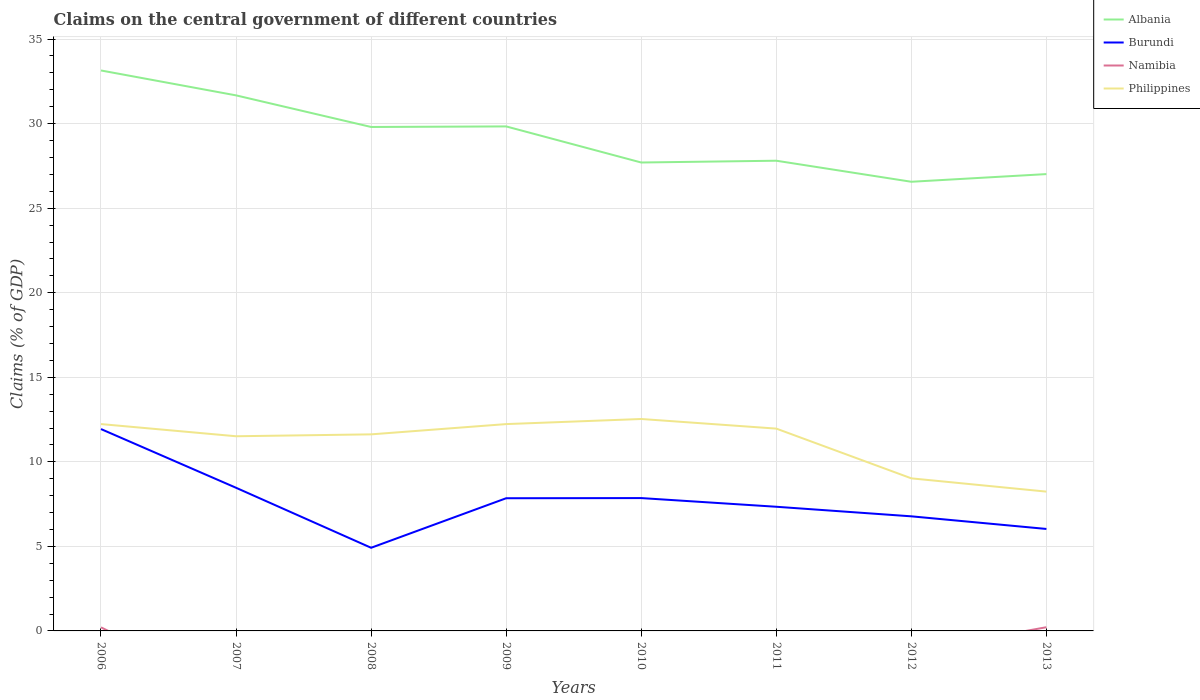Across all years, what is the maximum percentage of GDP claimed on the central government in Burundi?
Make the answer very short. 4.92. What is the total percentage of GDP claimed on the central government in Philippines in the graph?
Provide a succinct answer. 3.39. What is the difference between the highest and the second highest percentage of GDP claimed on the central government in Namibia?
Your answer should be compact. 0.22. What is the difference between the highest and the lowest percentage of GDP claimed on the central government in Philippines?
Your response must be concise. 6. How many lines are there?
Keep it short and to the point. 4. How many years are there in the graph?
Your answer should be very brief. 8. What is the difference between two consecutive major ticks on the Y-axis?
Keep it short and to the point. 5. Does the graph contain any zero values?
Keep it short and to the point. Yes. Where does the legend appear in the graph?
Your answer should be compact. Top right. How many legend labels are there?
Your response must be concise. 4. What is the title of the graph?
Your answer should be compact. Claims on the central government of different countries. Does "Kazakhstan" appear as one of the legend labels in the graph?
Provide a succinct answer. No. What is the label or title of the X-axis?
Provide a succinct answer. Years. What is the label or title of the Y-axis?
Give a very brief answer. Claims (% of GDP). What is the Claims (% of GDP) in Albania in 2006?
Keep it short and to the point. 33.14. What is the Claims (% of GDP) of Burundi in 2006?
Offer a very short reply. 11.94. What is the Claims (% of GDP) in Namibia in 2006?
Ensure brevity in your answer.  0.21. What is the Claims (% of GDP) of Philippines in 2006?
Give a very brief answer. 12.23. What is the Claims (% of GDP) of Albania in 2007?
Your answer should be compact. 31.67. What is the Claims (% of GDP) of Burundi in 2007?
Offer a very short reply. 8.47. What is the Claims (% of GDP) of Philippines in 2007?
Provide a short and direct response. 11.51. What is the Claims (% of GDP) in Albania in 2008?
Provide a succinct answer. 29.8. What is the Claims (% of GDP) in Burundi in 2008?
Your response must be concise. 4.92. What is the Claims (% of GDP) of Namibia in 2008?
Ensure brevity in your answer.  0. What is the Claims (% of GDP) in Philippines in 2008?
Your answer should be compact. 11.62. What is the Claims (% of GDP) of Albania in 2009?
Ensure brevity in your answer.  29.83. What is the Claims (% of GDP) of Burundi in 2009?
Ensure brevity in your answer.  7.85. What is the Claims (% of GDP) in Philippines in 2009?
Offer a terse response. 12.23. What is the Claims (% of GDP) of Albania in 2010?
Ensure brevity in your answer.  27.7. What is the Claims (% of GDP) in Burundi in 2010?
Your response must be concise. 7.86. What is the Claims (% of GDP) of Philippines in 2010?
Make the answer very short. 12.53. What is the Claims (% of GDP) in Albania in 2011?
Provide a succinct answer. 27.81. What is the Claims (% of GDP) in Burundi in 2011?
Your answer should be very brief. 7.34. What is the Claims (% of GDP) in Namibia in 2011?
Keep it short and to the point. 0. What is the Claims (% of GDP) in Philippines in 2011?
Your response must be concise. 11.96. What is the Claims (% of GDP) of Albania in 2012?
Make the answer very short. 26.56. What is the Claims (% of GDP) in Burundi in 2012?
Ensure brevity in your answer.  6.78. What is the Claims (% of GDP) of Namibia in 2012?
Your answer should be very brief. 0. What is the Claims (% of GDP) in Philippines in 2012?
Your response must be concise. 9.02. What is the Claims (% of GDP) of Albania in 2013?
Your answer should be very brief. 27.02. What is the Claims (% of GDP) in Burundi in 2013?
Offer a terse response. 6.03. What is the Claims (% of GDP) in Namibia in 2013?
Keep it short and to the point. 0.22. What is the Claims (% of GDP) in Philippines in 2013?
Offer a very short reply. 8.24. Across all years, what is the maximum Claims (% of GDP) of Albania?
Ensure brevity in your answer.  33.14. Across all years, what is the maximum Claims (% of GDP) in Burundi?
Your response must be concise. 11.94. Across all years, what is the maximum Claims (% of GDP) in Namibia?
Keep it short and to the point. 0.22. Across all years, what is the maximum Claims (% of GDP) in Philippines?
Provide a succinct answer. 12.53. Across all years, what is the minimum Claims (% of GDP) of Albania?
Your answer should be very brief. 26.56. Across all years, what is the minimum Claims (% of GDP) of Burundi?
Your answer should be very brief. 4.92. Across all years, what is the minimum Claims (% of GDP) of Namibia?
Your answer should be very brief. 0. Across all years, what is the minimum Claims (% of GDP) of Philippines?
Make the answer very short. 8.24. What is the total Claims (% of GDP) in Albania in the graph?
Provide a short and direct response. 233.54. What is the total Claims (% of GDP) of Burundi in the graph?
Provide a short and direct response. 61.17. What is the total Claims (% of GDP) of Namibia in the graph?
Give a very brief answer. 0.43. What is the total Claims (% of GDP) of Philippines in the graph?
Your answer should be compact. 89.36. What is the difference between the Claims (% of GDP) in Albania in 2006 and that in 2007?
Your response must be concise. 1.47. What is the difference between the Claims (% of GDP) in Burundi in 2006 and that in 2007?
Offer a very short reply. 3.47. What is the difference between the Claims (% of GDP) of Philippines in 2006 and that in 2007?
Keep it short and to the point. 0.72. What is the difference between the Claims (% of GDP) of Albania in 2006 and that in 2008?
Give a very brief answer. 3.34. What is the difference between the Claims (% of GDP) of Burundi in 2006 and that in 2008?
Your answer should be very brief. 7.02. What is the difference between the Claims (% of GDP) in Philippines in 2006 and that in 2008?
Offer a terse response. 0.61. What is the difference between the Claims (% of GDP) in Albania in 2006 and that in 2009?
Offer a terse response. 3.31. What is the difference between the Claims (% of GDP) in Burundi in 2006 and that in 2009?
Provide a short and direct response. 4.09. What is the difference between the Claims (% of GDP) of Philippines in 2006 and that in 2009?
Give a very brief answer. 0. What is the difference between the Claims (% of GDP) of Albania in 2006 and that in 2010?
Your answer should be very brief. 5.44. What is the difference between the Claims (% of GDP) in Burundi in 2006 and that in 2010?
Give a very brief answer. 4.08. What is the difference between the Claims (% of GDP) in Philippines in 2006 and that in 2010?
Your answer should be very brief. -0.3. What is the difference between the Claims (% of GDP) in Albania in 2006 and that in 2011?
Your answer should be very brief. 5.34. What is the difference between the Claims (% of GDP) of Burundi in 2006 and that in 2011?
Give a very brief answer. 4.59. What is the difference between the Claims (% of GDP) in Philippines in 2006 and that in 2011?
Offer a terse response. 0.27. What is the difference between the Claims (% of GDP) of Albania in 2006 and that in 2012?
Your answer should be compact. 6.58. What is the difference between the Claims (% of GDP) in Burundi in 2006 and that in 2012?
Keep it short and to the point. 5.16. What is the difference between the Claims (% of GDP) of Philippines in 2006 and that in 2012?
Your response must be concise. 3.21. What is the difference between the Claims (% of GDP) in Albania in 2006 and that in 2013?
Your answer should be very brief. 6.13. What is the difference between the Claims (% of GDP) of Burundi in 2006 and that in 2013?
Keep it short and to the point. 5.91. What is the difference between the Claims (% of GDP) of Namibia in 2006 and that in 2013?
Offer a very short reply. -0.01. What is the difference between the Claims (% of GDP) in Philippines in 2006 and that in 2013?
Provide a short and direct response. 3.99. What is the difference between the Claims (% of GDP) in Albania in 2007 and that in 2008?
Ensure brevity in your answer.  1.87. What is the difference between the Claims (% of GDP) in Burundi in 2007 and that in 2008?
Your answer should be compact. 3.55. What is the difference between the Claims (% of GDP) in Philippines in 2007 and that in 2008?
Ensure brevity in your answer.  -0.11. What is the difference between the Claims (% of GDP) in Albania in 2007 and that in 2009?
Make the answer very short. 1.84. What is the difference between the Claims (% of GDP) of Burundi in 2007 and that in 2009?
Offer a very short reply. 0.62. What is the difference between the Claims (% of GDP) of Philippines in 2007 and that in 2009?
Keep it short and to the point. -0.72. What is the difference between the Claims (% of GDP) of Albania in 2007 and that in 2010?
Provide a short and direct response. 3.97. What is the difference between the Claims (% of GDP) in Burundi in 2007 and that in 2010?
Offer a terse response. 0.61. What is the difference between the Claims (% of GDP) of Philippines in 2007 and that in 2010?
Make the answer very short. -1.02. What is the difference between the Claims (% of GDP) in Albania in 2007 and that in 2011?
Your response must be concise. 3.86. What is the difference between the Claims (% of GDP) in Burundi in 2007 and that in 2011?
Give a very brief answer. 1.12. What is the difference between the Claims (% of GDP) in Philippines in 2007 and that in 2011?
Make the answer very short. -0.45. What is the difference between the Claims (% of GDP) in Albania in 2007 and that in 2012?
Offer a terse response. 5.11. What is the difference between the Claims (% of GDP) of Burundi in 2007 and that in 2012?
Offer a terse response. 1.69. What is the difference between the Claims (% of GDP) in Philippines in 2007 and that in 2012?
Make the answer very short. 2.49. What is the difference between the Claims (% of GDP) in Albania in 2007 and that in 2013?
Make the answer very short. 4.66. What is the difference between the Claims (% of GDP) in Burundi in 2007 and that in 2013?
Offer a very short reply. 2.44. What is the difference between the Claims (% of GDP) of Philippines in 2007 and that in 2013?
Offer a very short reply. 3.27. What is the difference between the Claims (% of GDP) of Albania in 2008 and that in 2009?
Give a very brief answer. -0.03. What is the difference between the Claims (% of GDP) in Burundi in 2008 and that in 2009?
Your answer should be very brief. -2.93. What is the difference between the Claims (% of GDP) of Philippines in 2008 and that in 2009?
Your response must be concise. -0.61. What is the difference between the Claims (% of GDP) of Albania in 2008 and that in 2010?
Keep it short and to the point. 2.1. What is the difference between the Claims (% of GDP) in Burundi in 2008 and that in 2010?
Make the answer very short. -2.94. What is the difference between the Claims (% of GDP) in Philippines in 2008 and that in 2010?
Keep it short and to the point. -0.91. What is the difference between the Claims (% of GDP) of Albania in 2008 and that in 2011?
Make the answer very short. 2. What is the difference between the Claims (% of GDP) in Burundi in 2008 and that in 2011?
Make the answer very short. -2.43. What is the difference between the Claims (% of GDP) of Philippines in 2008 and that in 2011?
Provide a short and direct response. -0.34. What is the difference between the Claims (% of GDP) of Albania in 2008 and that in 2012?
Your answer should be very brief. 3.24. What is the difference between the Claims (% of GDP) of Burundi in 2008 and that in 2012?
Ensure brevity in your answer.  -1.86. What is the difference between the Claims (% of GDP) of Philippines in 2008 and that in 2012?
Your response must be concise. 2.6. What is the difference between the Claims (% of GDP) in Albania in 2008 and that in 2013?
Ensure brevity in your answer.  2.79. What is the difference between the Claims (% of GDP) in Burundi in 2008 and that in 2013?
Provide a short and direct response. -1.11. What is the difference between the Claims (% of GDP) in Philippines in 2008 and that in 2013?
Make the answer very short. 3.39. What is the difference between the Claims (% of GDP) in Albania in 2009 and that in 2010?
Your answer should be compact. 2.13. What is the difference between the Claims (% of GDP) in Burundi in 2009 and that in 2010?
Provide a short and direct response. -0.01. What is the difference between the Claims (% of GDP) of Philippines in 2009 and that in 2010?
Keep it short and to the point. -0.3. What is the difference between the Claims (% of GDP) of Albania in 2009 and that in 2011?
Offer a terse response. 2.03. What is the difference between the Claims (% of GDP) of Burundi in 2009 and that in 2011?
Your answer should be very brief. 0.5. What is the difference between the Claims (% of GDP) in Philippines in 2009 and that in 2011?
Offer a very short reply. 0.27. What is the difference between the Claims (% of GDP) of Albania in 2009 and that in 2012?
Your response must be concise. 3.27. What is the difference between the Claims (% of GDP) in Burundi in 2009 and that in 2012?
Your answer should be very brief. 1.07. What is the difference between the Claims (% of GDP) of Philippines in 2009 and that in 2012?
Your response must be concise. 3.21. What is the difference between the Claims (% of GDP) in Albania in 2009 and that in 2013?
Give a very brief answer. 2.82. What is the difference between the Claims (% of GDP) in Burundi in 2009 and that in 2013?
Offer a very short reply. 1.82. What is the difference between the Claims (% of GDP) of Philippines in 2009 and that in 2013?
Give a very brief answer. 3.99. What is the difference between the Claims (% of GDP) of Albania in 2010 and that in 2011?
Your answer should be compact. -0.11. What is the difference between the Claims (% of GDP) of Burundi in 2010 and that in 2011?
Keep it short and to the point. 0.51. What is the difference between the Claims (% of GDP) of Philippines in 2010 and that in 2011?
Provide a succinct answer. 0.57. What is the difference between the Claims (% of GDP) of Albania in 2010 and that in 2012?
Your answer should be compact. 1.14. What is the difference between the Claims (% of GDP) of Burundi in 2010 and that in 2012?
Provide a short and direct response. 1.08. What is the difference between the Claims (% of GDP) of Philippines in 2010 and that in 2012?
Provide a short and direct response. 3.51. What is the difference between the Claims (% of GDP) of Albania in 2010 and that in 2013?
Your response must be concise. 0.69. What is the difference between the Claims (% of GDP) of Burundi in 2010 and that in 2013?
Your answer should be compact. 1.83. What is the difference between the Claims (% of GDP) of Philippines in 2010 and that in 2013?
Your response must be concise. 4.3. What is the difference between the Claims (% of GDP) of Albania in 2011 and that in 2012?
Provide a succinct answer. 1.24. What is the difference between the Claims (% of GDP) of Burundi in 2011 and that in 2012?
Provide a succinct answer. 0.57. What is the difference between the Claims (% of GDP) of Philippines in 2011 and that in 2012?
Make the answer very short. 2.94. What is the difference between the Claims (% of GDP) of Albania in 2011 and that in 2013?
Offer a terse response. 0.79. What is the difference between the Claims (% of GDP) in Burundi in 2011 and that in 2013?
Your answer should be very brief. 1.31. What is the difference between the Claims (% of GDP) of Philippines in 2011 and that in 2013?
Keep it short and to the point. 3.73. What is the difference between the Claims (% of GDP) of Albania in 2012 and that in 2013?
Your answer should be compact. -0.45. What is the difference between the Claims (% of GDP) of Burundi in 2012 and that in 2013?
Your answer should be compact. 0.75. What is the difference between the Claims (% of GDP) of Philippines in 2012 and that in 2013?
Ensure brevity in your answer.  0.79. What is the difference between the Claims (% of GDP) in Albania in 2006 and the Claims (% of GDP) in Burundi in 2007?
Your answer should be very brief. 24.68. What is the difference between the Claims (% of GDP) in Albania in 2006 and the Claims (% of GDP) in Philippines in 2007?
Offer a very short reply. 21.63. What is the difference between the Claims (% of GDP) in Burundi in 2006 and the Claims (% of GDP) in Philippines in 2007?
Your answer should be compact. 0.43. What is the difference between the Claims (% of GDP) of Namibia in 2006 and the Claims (% of GDP) of Philippines in 2007?
Keep it short and to the point. -11.3. What is the difference between the Claims (% of GDP) in Albania in 2006 and the Claims (% of GDP) in Burundi in 2008?
Provide a succinct answer. 28.23. What is the difference between the Claims (% of GDP) in Albania in 2006 and the Claims (% of GDP) in Philippines in 2008?
Provide a short and direct response. 21.52. What is the difference between the Claims (% of GDP) of Burundi in 2006 and the Claims (% of GDP) of Philippines in 2008?
Provide a succinct answer. 0.31. What is the difference between the Claims (% of GDP) in Namibia in 2006 and the Claims (% of GDP) in Philippines in 2008?
Make the answer very short. -11.41. What is the difference between the Claims (% of GDP) in Albania in 2006 and the Claims (% of GDP) in Burundi in 2009?
Provide a short and direct response. 25.3. What is the difference between the Claims (% of GDP) of Albania in 2006 and the Claims (% of GDP) of Philippines in 2009?
Give a very brief answer. 20.91. What is the difference between the Claims (% of GDP) of Burundi in 2006 and the Claims (% of GDP) of Philippines in 2009?
Make the answer very short. -0.29. What is the difference between the Claims (% of GDP) in Namibia in 2006 and the Claims (% of GDP) in Philippines in 2009?
Provide a short and direct response. -12.02. What is the difference between the Claims (% of GDP) in Albania in 2006 and the Claims (% of GDP) in Burundi in 2010?
Make the answer very short. 25.29. What is the difference between the Claims (% of GDP) in Albania in 2006 and the Claims (% of GDP) in Philippines in 2010?
Provide a short and direct response. 20.61. What is the difference between the Claims (% of GDP) of Burundi in 2006 and the Claims (% of GDP) of Philippines in 2010?
Ensure brevity in your answer.  -0.6. What is the difference between the Claims (% of GDP) of Namibia in 2006 and the Claims (% of GDP) of Philippines in 2010?
Your answer should be compact. -12.32. What is the difference between the Claims (% of GDP) of Albania in 2006 and the Claims (% of GDP) of Burundi in 2011?
Give a very brief answer. 25.8. What is the difference between the Claims (% of GDP) of Albania in 2006 and the Claims (% of GDP) of Philippines in 2011?
Ensure brevity in your answer.  21.18. What is the difference between the Claims (% of GDP) of Burundi in 2006 and the Claims (% of GDP) of Philippines in 2011?
Provide a short and direct response. -0.03. What is the difference between the Claims (% of GDP) of Namibia in 2006 and the Claims (% of GDP) of Philippines in 2011?
Offer a very short reply. -11.75. What is the difference between the Claims (% of GDP) of Albania in 2006 and the Claims (% of GDP) of Burundi in 2012?
Give a very brief answer. 26.37. What is the difference between the Claims (% of GDP) of Albania in 2006 and the Claims (% of GDP) of Philippines in 2012?
Your answer should be compact. 24.12. What is the difference between the Claims (% of GDP) in Burundi in 2006 and the Claims (% of GDP) in Philippines in 2012?
Your response must be concise. 2.91. What is the difference between the Claims (% of GDP) of Namibia in 2006 and the Claims (% of GDP) of Philippines in 2012?
Ensure brevity in your answer.  -8.81. What is the difference between the Claims (% of GDP) of Albania in 2006 and the Claims (% of GDP) of Burundi in 2013?
Offer a terse response. 27.11. What is the difference between the Claims (% of GDP) in Albania in 2006 and the Claims (% of GDP) in Namibia in 2013?
Your answer should be very brief. 32.92. What is the difference between the Claims (% of GDP) in Albania in 2006 and the Claims (% of GDP) in Philippines in 2013?
Your response must be concise. 24.91. What is the difference between the Claims (% of GDP) of Burundi in 2006 and the Claims (% of GDP) of Namibia in 2013?
Provide a short and direct response. 11.72. What is the difference between the Claims (% of GDP) of Burundi in 2006 and the Claims (% of GDP) of Philippines in 2013?
Keep it short and to the point. 3.7. What is the difference between the Claims (% of GDP) of Namibia in 2006 and the Claims (% of GDP) of Philippines in 2013?
Your answer should be very brief. -8.03. What is the difference between the Claims (% of GDP) in Albania in 2007 and the Claims (% of GDP) in Burundi in 2008?
Ensure brevity in your answer.  26.75. What is the difference between the Claims (% of GDP) in Albania in 2007 and the Claims (% of GDP) in Philippines in 2008?
Ensure brevity in your answer.  20.05. What is the difference between the Claims (% of GDP) of Burundi in 2007 and the Claims (% of GDP) of Philippines in 2008?
Offer a very short reply. -3.16. What is the difference between the Claims (% of GDP) in Albania in 2007 and the Claims (% of GDP) in Burundi in 2009?
Make the answer very short. 23.82. What is the difference between the Claims (% of GDP) in Albania in 2007 and the Claims (% of GDP) in Philippines in 2009?
Your response must be concise. 19.44. What is the difference between the Claims (% of GDP) of Burundi in 2007 and the Claims (% of GDP) of Philippines in 2009?
Provide a succinct answer. -3.77. What is the difference between the Claims (% of GDP) in Albania in 2007 and the Claims (% of GDP) in Burundi in 2010?
Offer a very short reply. 23.82. What is the difference between the Claims (% of GDP) in Albania in 2007 and the Claims (% of GDP) in Philippines in 2010?
Keep it short and to the point. 19.14. What is the difference between the Claims (% of GDP) in Burundi in 2007 and the Claims (% of GDP) in Philippines in 2010?
Your response must be concise. -4.07. What is the difference between the Claims (% of GDP) of Albania in 2007 and the Claims (% of GDP) of Burundi in 2011?
Keep it short and to the point. 24.33. What is the difference between the Claims (% of GDP) in Albania in 2007 and the Claims (% of GDP) in Philippines in 2011?
Your response must be concise. 19.71. What is the difference between the Claims (% of GDP) in Burundi in 2007 and the Claims (% of GDP) in Philippines in 2011?
Your answer should be very brief. -3.5. What is the difference between the Claims (% of GDP) in Albania in 2007 and the Claims (% of GDP) in Burundi in 2012?
Ensure brevity in your answer.  24.89. What is the difference between the Claims (% of GDP) of Albania in 2007 and the Claims (% of GDP) of Philippines in 2012?
Your answer should be compact. 22.65. What is the difference between the Claims (% of GDP) in Burundi in 2007 and the Claims (% of GDP) in Philippines in 2012?
Your response must be concise. -0.56. What is the difference between the Claims (% of GDP) of Albania in 2007 and the Claims (% of GDP) of Burundi in 2013?
Offer a very short reply. 25.64. What is the difference between the Claims (% of GDP) in Albania in 2007 and the Claims (% of GDP) in Namibia in 2013?
Make the answer very short. 31.45. What is the difference between the Claims (% of GDP) in Albania in 2007 and the Claims (% of GDP) in Philippines in 2013?
Provide a succinct answer. 23.43. What is the difference between the Claims (% of GDP) in Burundi in 2007 and the Claims (% of GDP) in Namibia in 2013?
Make the answer very short. 8.25. What is the difference between the Claims (% of GDP) in Burundi in 2007 and the Claims (% of GDP) in Philippines in 2013?
Make the answer very short. 0.23. What is the difference between the Claims (% of GDP) in Albania in 2008 and the Claims (% of GDP) in Burundi in 2009?
Offer a terse response. 21.96. What is the difference between the Claims (% of GDP) of Albania in 2008 and the Claims (% of GDP) of Philippines in 2009?
Make the answer very short. 17.57. What is the difference between the Claims (% of GDP) of Burundi in 2008 and the Claims (% of GDP) of Philippines in 2009?
Your response must be concise. -7.31. What is the difference between the Claims (% of GDP) of Albania in 2008 and the Claims (% of GDP) of Burundi in 2010?
Make the answer very short. 21.95. What is the difference between the Claims (% of GDP) of Albania in 2008 and the Claims (% of GDP) of Philippines in 2010?
Make the answer very short. 17.27. What is the difference between the Claims (% of GDP) of Burundi in 2008 and the Claims (% of GDP) of Philippines in 2010?
Your response must be concise. -7.62. What is the difference between the Claims (% of GDP) in Albania in 2008 and the Claims (% of GDP) in Burundi in 2011?
Your answer should be compact. 22.46. What is the difference between the Claims (% of GDP) of Albania in 2008 and the Claims (% of GDP) of Philippines in 2011?
Keep it short and to the point. 17.84. What is the difference between the Claims (% of GDP) in Burundi in 2008 and the Claims (% of GDP) in Philippines in 2011?
Make the answer very short. -7.05. What is the difference between the Claims (% of GDP) of Albania in 2008 and the Claims (% of GDP) of Burundi in 2012?
Offer a terse response. 23.03. What is the difference between the Claims (% of GDP) in Albania in 2008 and the Claims (% of GDP) in Philippines in 2012?
Make the answer very short. 20.78. What is the difference between the Claims (% of GDP) in Burundi in 2008 and the Claims (% of GDP) in Philippines in 2012?
Keep it short and to the point. -4.11. What is the difference between the Claims (% of GDP) of Albania in 2008 and the Claims (% of GDP) of Burundi in 2013?
Your answer should be very brief. 23.77. What is the difference between the Claims (% of GDP) of Albania in 2008 and the Claims (% of GDP) of Namibia in 2013?
Offer a very short reply. 29.58. What is the difference between the Claims (% of GDP) of Albania in 2008 and the Claims (% of GDP) of Philippines in 2013?
Make the answer very short. 21.56. What is the difference between the Claims (% of GDP) of Burundi in 2008 and the Claims (% of GDP) of Namibia in 2013?
Provide a succinct answer. 4.7. What is the difference between the Claims (% of GDP) in Burundi in 2008 and the Claims (% of GDP) in Philippines in 2013?
Your answer should be compact. -3.32. What is the difference between the Claims (% of GDP) in Albania in 2009 and the Claims (% of GDP) in Burundi in 2010?
Provide a short and direct response. 21.98. What is the difference between the Claims (% of GDP) in Albania in 2009 and the Claims (% of GDP) in Philippines in 2010?
Your answer should be very brief. 17.3. What is the difference between the Claims (% of GDP) of Burundi in 2009 and the Claims (% of GDP) of Philippines in 2010?
Offer a very short reply. -4.69. What is the difference between the Claims (% of GDP) of Albania in 2009 and the Claims (% of GDP) of Burundi in 2011?
Your answer should be compact. 22.49. What is the difference between the Claims (% of GDP) in Albania in 2009 and the Claims (% of GDP) in Philippines in 2011?
Your answer should be compact. 17.87. What is the difference between the Claims (% of GDP) in Burundi in 2009 and the Claims (% of GDP) in Philippines in 2011?
Your answer should be compact. -4.12. What is the difference between the Claims (% of GDP) in Albania in 2009 and the Claims (% of GDP) in Burundi in 2012?
Your answer should be compact. 23.06. What is the difference between the Claims (% of GDP) in Albania in 2009 and the Claims (% of GDP) in Philippines in 2012?
Provide a short and direct response. 20.81. What is the difference between the Claims (% of GDP) of Burundi in 2009 and the Claims (% of GDP) of Philippines in 2012?
Give a very brief answer. -1.18. What is the difference between the Claims (% of GDP) of Albania in 2009 and the Claims (% of GDP) of Burundi in 2013?
Provide a short and direct response. 23.8. What is the difference between the Claims (% of GDP) of Albania in 2009 and the Claims (% of GDP) of Namibia in 2013?
Your answer should be compact. 29.62. What is the difference between the Claims (% of GDP) in Albania in 2009 and the Claims (% of GDP) in Philippines in 2013?
Offer a terse response. 21.6. What is the difference between the Claims (% of GDP) in Burundi in 2009 and the Claims (% of GDP) in Namibia in 2013?
Provide a short and direct response. 7.63. What is the difference between the Claims (% of GDP) in Burundi in 2009 and the Claims (% of GDP) in Philippines in 2013?
Your response must be concise. -0.39. What is the difference between the Claims (% of GDP) in Albania in 2010 and the Claims (% of GDP) in Burundi in 2011?
Make the answer very short. 20.36. What is the difference between the Claims (% of GDP) in Albania in 2010 and the Claims (% of GDP) in Philippines in 2011?
Keep it short and to the point. 15.74. What is the difference between the Claims (% of GDP) of Burundi in 2010 and the Claims (% of GDP) of Philippines in 2011?
Provide a short and direct response. -4.11. What is the difference between the Claims (% of GDP) in Albania in 2010 and the Claims (% of GDP) in Burundi in 2012?
Make the answer very short. 20.92. What is the difference between the Claims (% of GDP) of Albania in 2010 and the Claims (% of GDP) of Philippines in 2012?
Offer a very short reply. 18.68. What is the difference between the Claims (% of GDP) of Burundi in 2010 and the Claims (% of GDP) of Philippines in 2012?
Offer a very short reply. -1.17. What is the difference between the Claims (% of GDP) of Albania in 2010 and the Claims (% of GDP) of Burundi in 2013?
Provide a succinct answer. 21.67. What is the difference between the Claims (% of GDP) in Albania in 2010 and the Claims (% of GDP) in Namibia in 2013?
Your answer should be very brief. 27.48. What is the difference between the Claims (% of GDP) in Albania in 2010 and the Claims (% of GDP) in Philippines in 2013?
Provide a succinct answer. 19.46. What is the difference between the Claims (% of GDP) in Burundi in 2010 and the Claims (% of GDP) in Namibia in 2013?
Your answer should be very brief. 7.64. What is the difference between the Claims (% of GDP) of Burundi in 2010 and the Claims (% of GDP) of Philippines in 2013?
Provide a succinct answer. -0.38. What is the difference between the Claims (% of GDP) in Albania in 2011 and the Claims (% of GDP) in Burundi in 2012?
Your answer should be very brief. 21.03. What is the difference between the Claims (% of GDP) in Albania in 2011 and the Claims (% of GDP) in Philippines in 2012?
Ensure brevity in your answer.  18.78. What is the difference between the Claims (% of GDP) in Burundi in 2011 and the Claims (% of GDP) in Philippines in 2012?
Offer a very short reply. -1.68. What is the difference between the Claims (% of GDP) of Albania in 2011 and the Claims (% of GDP) of Burundi in 2013?
Offer a terse response. 21.78. What is the difference between the Claims (% of GDP) in Albania in 2011 and the Claims (% of GDP) in Namibia in 2013?
Provide a succinct answer. 27.59. What is the difference between the Claims (% of GDP) in Albania in 2011 and the Claims (% of GDP) in Philippines in 2013?
Your answer should be very brief. 19.57. What is the difference between the Claims (% of GDP) of Burundi in 2011 and the Claims (% of GDP) of Namibia in 2013?
Provide a short and direct response. 7.12. What is the difference between the Claims (% of GDP) of Burundi in 2011 and the Claims (% of GDP) of Philippines in 2013?
Keep it short and to the point. -0.9. What is the difference between the Claims (% of GDP) in Albania in 2012 and the Claims (% of GDP) in Burundi in 2013?
Keep it short and to the point. 20.53. What is the difference between the Claims (% of GDP) in Albania in 2012 and the Claims (% of GDP) in Namibia in 2013?
Keep it short and to the point. 26.34. What is the difference between the Claims (% of GDP) in Albania in 2012 and the Claims (% of GDP) in Philippines in 2013?
Your response must be concise. 18.32. What is the difference between the Claims (% of GDP) of Burundi in 2012 and the Claims (% of GDP) of Namibia in 2013?
Offer a very short reply. 6.56. What is the difference between the Claims (% of GDP) of Burundi in 2012 and the Claims (% of GDP) of Philippines in 2013?
Make the answer very short. -1.46. What is the average Claims (% of GDP) of Albania per year?
Provide a succinct answer. 29.19. What is the average Claims (% of GDP) in Burundi per year?
Offer a terse response. 7.65. What is the average Claims (% of GDP) of Namibia per year?
Your answer should be compact. 0.05. What is the average Claims (% of GDP) of Philippines per year?
Provide a short and direct response. 11.17. In the year 2006, what is the difference between the Claims (% of GDP) in Albania and Claims (% of GDP) in Burundi?
Your response must be concise. 21.21. In the year 2006, what is the difference between the Claims (% of GDP) of Albania and Claims (% of GDP) of Namibia?
Your answer should be compact. 32.93. In the year 2006, what is the difference between the Claims (% of GDP) of Albania and Claims (% of GDP) of Philippines?
Give a very brief answer. 20.91. In the year 2006, what is the difference between the Claims (% of GDP) in Burundi and Claims (% of GDP) in Namibia?
Keep it short and to the point. 11.73. In the year 2006, what is the difference between the Claims (% of GDP) of Burundi and Claims (% of GDP) of Philippines?
Make the answer very short. -0.29. In the year 2006, what is the difference between the Claims (% of GDP) in Namibia and Claims (% of GDP) in Philippines?
Make the answer very short. -12.02. In the year 2007, what is the difference between the Claims (% of GDP) of Albania and Claims (% of GDP) of Burundi?
Provide a short and direct response. 23.21. In the year 2007, what is the difference between the Claims (% of GDP) of Albania and Claims (% of GDP) of Philippines?
Ensure brevity in your answer.  20.16. In the year 2007, what is the difference between the Claims (% of GDP) in Burundi and Claims (% of GDP) in Philippines?
Offer a very short reply. -3.05. In the year 2008, what is the difference between the Claims (% of GDP) in Albania and Claims (% of GDP) in Burundi?
Your answer should be very brief. 24.89. In the year 2008, what is the difference between the Claims (% of GDP) of Albania and Claims (% of GDP) of Philippines?
Your answer should be compact. 18.18. In the year 2008, what is the difference between the Claims (% of GDP) in Burundi and Claims (% of GDP) in Philippines?
Your response must be concise. -6.71. In the year 2009, what is the difference between the Claims (% of GDP) of Albania and Claims (% of GDP) of Burundi?
Offer a terse response. 21.99. In the year 2009, what is the difference between the Claims (% of GDP) of Albania and Claims (% of GDP) of Philippines?
Provide a succinct answer. 17.6. In the year 2009, what is the difference between the Claims (% of GDP) of Burundi and Claims (% of GDP) of Philippines?
Provide a short and direct response. -4.38. In the year 2010, what is the difference between the Claims (% of GDP) in Albania and Claims (% of GDP) in Burundi?
Your response must be concise. 19.85. In the year 2010, what is the difference between the Claims (% of GDP) in Albania and Claims (% of GDP) in Philippines?
Your answer should be very brief. 15.17. In the year 2010, what is the difference between the Claims (% of GDP) in Burundi and Claims (% of GDP) in Philippines?
Offer a terse response. -4.68. In the year 2011, what is the difference between the Claims (% of GDP) of Albania and Claims (% of GDP) of Burundi?
Ensure brevity in your answer.  20.46. In the year 2011, what is the difference between the Claims (% of GDP) in Albania and Claims (% of GDP) in Philippines?
Your answer should be compact. 15.84. In the year 2011, what is the difference between the Claims (% of GDP) of Burundi and Claims (% of GDP) of Philippines?
Provide a short and direct response. -4.62. In the year 2012, what is the difference between the Claims (% of GDP) of Albania and Claims (% of GDP) of Burundi?
Ensure brevity in your answer.  19.79. In the year 2012, what is the difference between the Claims (% of GDP) of Albania and Claims (% of GDP) of Philippines?
Your response must be concise. 17.54. In the year 2012, what is the difference between the Claims (% of GDP) of Burundi and Claims (% of GDP) of Philippines?
Provide a succinct answer. -2.25. In the year 2013, what is the difference between the Claims (% of GDP) in Albania and Claims (% of GDP) in Burundi?
Offer a very short reply. 20.99. In the year 2013, what is the difference between the Claims (% of GDP) in Albania and Claims (% of GDP) in Namibia?
Keep it short and to the point. 26.8. In the year 2013, what is the difference between the Claims (% of GDP) of Albania and Claims (% of GDP) of Philippines?
Ensure brevity in your answer.  18.78. In the year 2013, what is the difference between the Claims (% of GDP) of Burundi and Claims (% of GDP) of Namibia?
Offer a very short reply. 5.81. In the year 2013, what is the difference between the Claims (% of GDP) of Burundi and Claims (% of GDP) of Philippines?
Keep it short and to the point. -2.21. In the year 2013, what is the difference between the Claims (% of GDP) in Namibia and Claims (% of GDP) in Philippines?
Your answer should be compact. -8.02. What is the ratio of the Claims (% of GDP) in Albania in 2006 to that in 2007?
Offer a very short reply. 1.05. What is the ratio of the Claims (% of GDP) of Burundi in 2006 to that in 2007?
Give a very brief answer. 1.41. What is the ratio of the Claims (% of GDP) in Albania in 2006 to that in 2008?
Give a very brief answer. 1.11. What is the ratio of the Claims (% of GDP) in Burundi in 2006 to that in 2008?
Make the answer very short. 2.43. What is the ratio of the Claims (% of GDP) of Philippines in 2006 to that in 2008?
Provide a short and direct response. 1.05. What is the ratio of the Claims (% of GDP) of Albania in 2006 to that in 2009?
Your answer should be compact. 1.11. What is the ratio of the Claims (% of GDP) of Burundi in 2006 to that in 2009?
Give a very brief answer. 1.52. What is the ratio of the Claims (% of GDP) of Albania in 2006 to that in 2010?
Offer a terse response. 1.2. What is the ratio of the Claims (% of GDP) of Burundi in 2006 to that in 2010?
Provide a succinct answer. 1.52. What is the ratio of the Claims (% of GDP) in Albania in 2006 to that in 2011?
Provide a short and direct response. 1.19. What is the ratio of the Claims (% of GDP) of Burundi in 2006 to that in 2011?
Your answer should be compact. 1.63. What is the ratio of the Claims (% of GDP) of Philippines in 2006 to that in 2011?
Provide a succinct answer. 1.02. What is the ratio of the Claims (% of GDP) in Albania in 2006 to that in 2012?
Provide a short and direct response. 1.25. What is the ratio of the Claims (% of GDP) of Burundi in 2006 to that in 2012?
Provide a succinct answer. 1.76. What is the ratio of the Claims (% of GDP) of Philippines in 2006 to that in 2012?
Provide a succinct answer. 1.36. What is the ratio of the Claims (% of GDP) in Albania in 2006 to that in 2013?
Give a very brief answer. 1.23. What is the ratio of the Claims (% of GDP) in Burundi in 2006 to that in 2013?
Offer a terse response. 1.98. What is the ratio of the Claims (% of GDP) in Namibia in 2006 to that in 2013?
Your response must be concise. 0.96. What is the ratio of the Claims (% of GDP) of Philippines in 2006 to that in 2013?
Ensure brevity in your answer.  1.48. What is the ratio of the Claims (% of GDP) of Albania in 2007 to that in 2008?
Give a very brief answer. 1.06. What is the ratio of the Claims (% of GDP) in Burundi in 2007 to that in 2008?
Offer a terse response. 1.72. What is the ratio of the Claims (% of GDP) of Albania in 2007 to that in 2009?
Provide a short and direct response. 1.06. What is the ratio of the Claims (% of GDP) of Burundi in 2007 to that in 2009?
Keep it short and to the point. 1.08. What is the ratio of the Claims (% of GDP) in Albania in 2007 to that in 2010?
Your answer should be very brief. 1.14. What is the ratio of the Claims (% of GDP) of Burundi in 2007 to that in 2010?
Your response must be concise. 1.08. What is the ratio of the Claims (% of GDP) of Philippines in 2007 to that in 2010?
Your answer should be compact. 0.92. What is the ratio of the Claims (% of GDP) in Albania in 2007 to that in 2011?
Make the answer very short. 1.14. What is the ratio of the Claims (% of GDP) in Burundi in 2007 to that in 2011?
Your response must be concise. 1.15. What is the ratio of the Claims (% of GDP) of Philippines in 2007 to that in 2011?
Keep it short and to the point. 0.96. What is the ratio of the Claims (% of GDP) of Albania in 2007 to that in 2012?
Your answer should be very brief. 1.19. What is the ratio of the Claims (% of GDP) in Burundi in 2007 to that in 2012?
Your answer should be compact. 1.25. What is the ratio of the Claims (% of GDP) of Philippines in 2007 to that in 2012?
Provide a succinct answer. 1.28. What is the ratio of the Claims (% of GDP) in Albania in 2007 to that in 2013?
Your answer should be compact. 1.17. What is the ratio of the Claims (% of GDP) of Burundi in 2007 to that in 2013?
Give a very brief answer. 1.4. What is the ratio of the Claims (% of GDP) in Philippines in 2007 to that in 2013?
Your answer should be very brief. 1.4. What is the ratio of the Claims (% of GDP) of Albania in 2008 to that in 2009?
Your answer should be very brief. 1. What is the ratio of the Claims (% of GDP) in Burundi in 2008 to that in 2009?
Your answer should be compact. 0.63. What is the ratio of the Claims (% of GDP) in Philippines in 2008 to that in 2009?
Make the answer very short. 0.95. What is the ratio of the Claims (% of GDP) of Albania in 2008 to that in 2010?
Your answer should be compact. 1.08. What is the ratio of the Claims (% of GDP) in Burundi in 2008 to that in 2010?
Make the answer very short. 0.63. What is the ratio of the Claims (% of GDP) of Philippines in 2008 to that in 2010?
Give a very brief answer. 0.93. What is the ratio of the Claims (% of GDP) in Albania in 2008 to that in 2011?
Make the answer very short. 1.07. What is the ratio of the Claims (% of GDP) in Burundi in 2008 to that in 2011?
Offer a terse response. 0.67. What is the ratio of the Claims (% of GDP) in Philippines in 2008 to that in 2011?
Provide a succinct answer. 0.97. What is the ratio of the Claims (% of GDP) of Albania in 2008 to that in 2012?
Keep it short and to the point. 1.12. What is the ratio of the Claims (% of GDP) of Burundi in 2008 to that in 2012?
Your answer should be compact. 0.73. What is the ratio of the Claims (% of GDP) in Philippines in 2008 to that in 2012?
Provide a short and direct response. 1.29. What is the ratio of the Claims (% of GDP) of Albania in 2008 to that in 2013?
Ensure brevity in your answer.  1.1. What is the ratio of the Claims (% of GDP) of Burundi in 2008 to that in 2013?
Your answer should be compact. 0.82. What is the ratio of the Claims (% of GDP) in Philippines in 2008 to that in 2013?
Ensure brevity in your answer.  1.41. What is the ratio of the Claims (% of GDP) in Albania in 2009 to that in 2010?
Offer a very short reply. 1.08. What is the ratio of the Claims (% of GDP) of Burundi in 2009 to that in 2010?
Your answer should be very brief. 1. What is the ratio of the Claims (% of GDP) of Philippines in 2009 to that in 2010?
Make the answer very short. 0.98. What is the ratio of the Claims (% of GDP) in Albania in 2009 to that in 2011?
Provide a short and direct response. 1.07. What is the ratio of the Claims (% of GDP) in Burundi in 2009 to that in 2011?
Your answer should be compact. 1.07. What is the ratio of the Claims (% of GDP) in Philippines in 2009 to that in 2011?
Give a very brief answer. 1.02. What is the ratio of the Claims (% of GDP) in Albania in 2009 to that in 2012?
Your response must be concise. 1.12. What is the ratio of the Claims (% of GDP) in Burundi in 2009 to that in 2012?
Keep it short and to the point. 1.16. What is the ratio of the Claims (% of GDP) in Philippines in 2009 to that in 2012?
Give a very brief answer. 1.36. What is the ratio of the Claims (% of GDP) in Albania in 2009 to that in 2013?
Provide a short and direct response. 1.1. What is the ratio of the Claims (% of GDP) in Burundi in 2009 to that in 2013?
Make the answer very short. 1.3. What is the ratio of the Claims (% of GDP) in Philippines in 2009 to that in 2013?
Your answer should be compact. 1.48. What is the ratio of the Claims (% of GDP) in Albania in 2010 to that in 2011?
Offer a terse response. 1. What is the ratio of the Claims (% of GDP) of Burundi in 2010 to that in 2011?
Make the answer very short. 1.07. What is the ratio of the Claims (% of GDP) in Philippines in 2010 to that in 2011?
Make the answer very short. 1.05. What is the ratio of the Claims (% of GDP) of Albania in 2010 to that in 2012?
Offer a terse response. 1.04. What is the ratio of the Claims (% of GDP) of Burundi in 2010 to that in 2012?
Make the answer very short. 1.16. What is the ratio of the Claims (% of GDP) in Philippines in 2010 to that in 2012?
Ensure brevity in your answer.  1.39. What is the ratio of the Claims (% of GDP) in Albania in 2010 to that in 2013?
Offer a terse response. 1.03. What is the ratio of the Claims (% of GDP) of Burundi in 2010 to that in 2013?
Provide a succinct answer. 1.3. What is the ratio of the Claims (% of GDP) in Philippines in 2010 to that in 2013?
Your response must be concise. 1.52. What is the ratio of the Claims (% of GDP) of Albania in 2011 to that in 2012?
Make the answer very short. 1.05. What is the ratio of the Claims (% of GDP) of Burundi in 2011 to that in 2012?
Provide a succinct answer. 1.08. What is the ratio of the Claims (% of GDP) in Philippines in 2011 to that in 2012?
Provide a short and direct response. 1.33. What is the ratio of the Claims (% of GDP) in Albania in 2011 to that in 2013?
Provide a short and direct response. 1.03. What is the ratio of the Claims (% of GDP) of Burundi in 2011 to that in 2013?
Your answer should be compact. 1.22. What is the ratio of the Claims (% of GDP) in Philippines in 2011 to that in 2013?
Provide a short and direct response. 1.45. What is the ratio of the Claims (% of GDP) of Albania in 2012 to that in 2013?
Provide a succinct answer. 0.98. What is the ratio of the Claims (% of GDP) in Burundi in 2012 to that in 2013?
Ensure brevity in your answer.  1.12. What is the ratio of the Claims (% of GDP) in Philippines in 2012 to that in 2013?
Offer a terse response. 1.1. What is the difference between the highest and the second highest Claims (% of GDP) of Albania?
Offer a very short reply. 1.47. What is the difference between the highest and the second highest Claims (% of GDP) in Burundi?
Offer a terse response. 3.47. What is the difference between the highest and the second highest Claims (% of GDP) of Philippines?
Offer a terse response. 0.3. What is the difference between the highest and the lowest Claims (% of GDP) of Albania?
Ensure brevity in your answer.  6.58. What is the difference between the highest and the lowest Claims (% of GDP) in Burundi?
Your answer should be compact. 7.02. What is the difference between the highest and the lowest Claims (% of GDP) of Namibia?
Provide a succinct answer. 0.22. What is the difference between the highest and the lowest Claims (% of GDP) in Philippines?
Offer a very short reply. 4.3. 